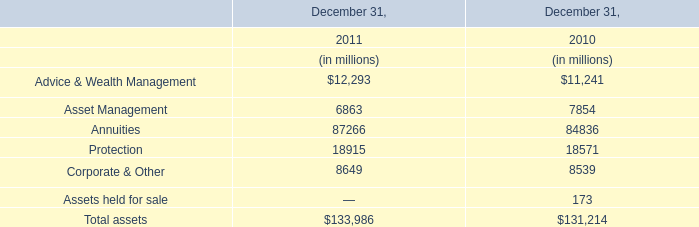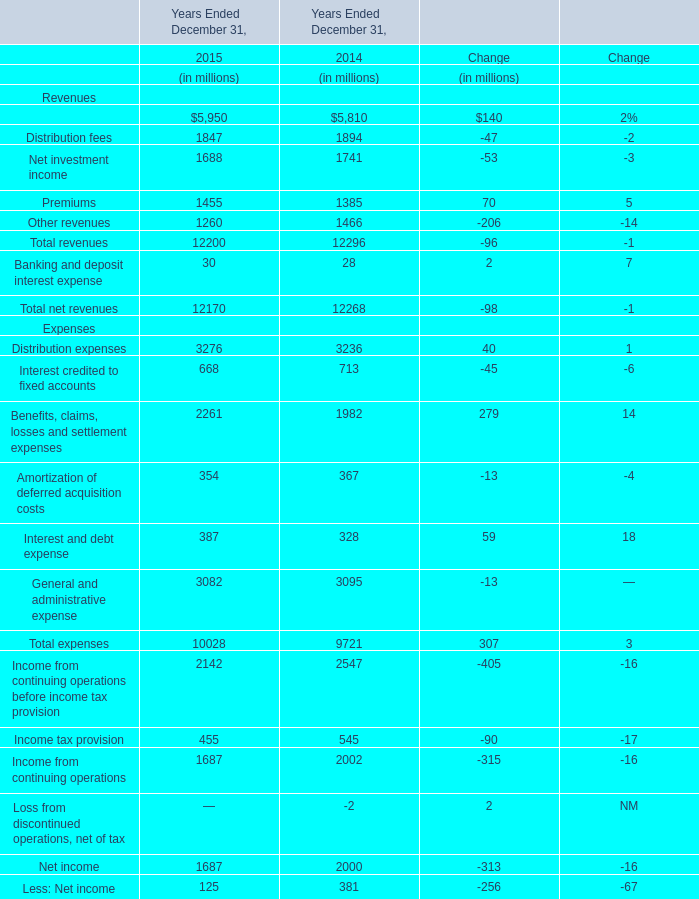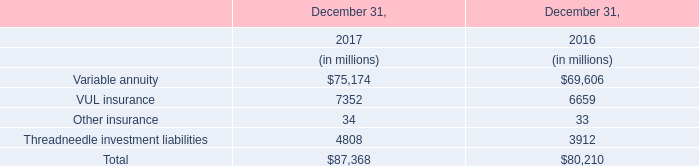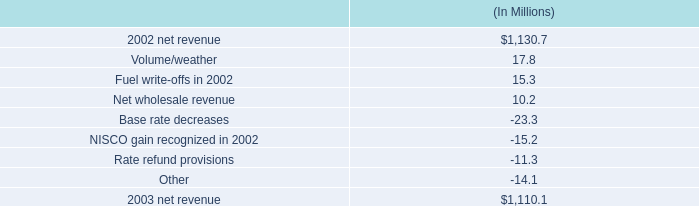What's the average of Management and financial advice fees and Distribution fees in 2015? (in millions) 
Computations: ((5950 + 1847) / 2)
Answer: 3898.5. 